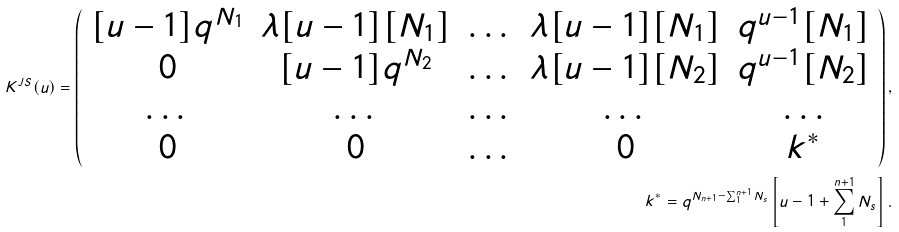<formula> <loc_0><loc_0><loc_500><loc_500>K ^ { J S } ( u ) = \left ( \begin{array} { c c c c c } [ u - 1 ] q ^ { N _ { 1 } } & \lambda [ u - 1 ] [ N _ { 1 } ] & \dots & \lambda [ u - 1 ] [ N _ { 1 } ] & q ^ { u - 1 } [ N _ { 1 } ] \\ 0 & [ u - 1 ] q ^ { N _ { 2 } } & \dots & \lambda [ u - 1 ] [ N _ { 2 } ] & q ^ { u - 1 } [ N _ { 2 } ] \\ \dots & \dots & \dots & \dots & \dots \\ 0 & 0 & \dots & 0 & k ^ { * } \\ \end{array} \right ) , \\ k ^ { * } = q ^ { N _ { n + 1 } - \sum _ { 1 } ^ { n + 1 } N _ { s } } \left [ u - 1 + \sum _ { 1 } ^ { n + 1 } N _ { s } \right ] .</formula> 